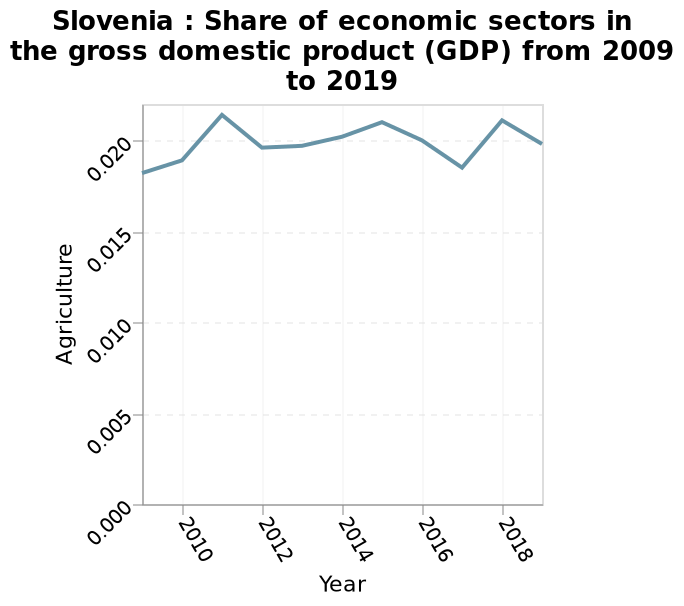<image>
Between which years does the line chart show data? The line chart shows data from 2009 to 2019. What is measured along the x-axis? Year is measured along the x-axis. please summary the statistics and relations of the chart The GDP HAS REMAINED QUITE SIMILAR IN THE ENTIRE LENGTH OF TIME IT HAS BEEN DOCUMENTED. What is the range of the y-axis scale? The y-axis scale ranges from 0.000 to 0.020. 